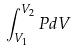Convert formula to latex. <formula><loc_0><loc_0><loc_500><loc_500>\int _ { V _ { 1 } } ^ { V _ { 2 } } P d V</formula> 